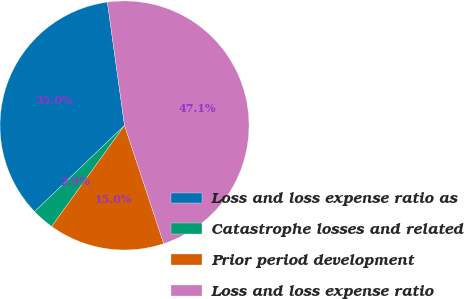Convert chart. <chart><loc_0><loc_0><loc_500><loc_500><pie_chart><fcel>Loss and loss expense ratio as<fcel>Catastrophe losses and related<fcel>Prior period development<fcel>Loss and loss expense ratio<nl><fcel>34.96%<fcel>2.9%<fcel>15.04%<fcel>47.1%<nl></chart> 